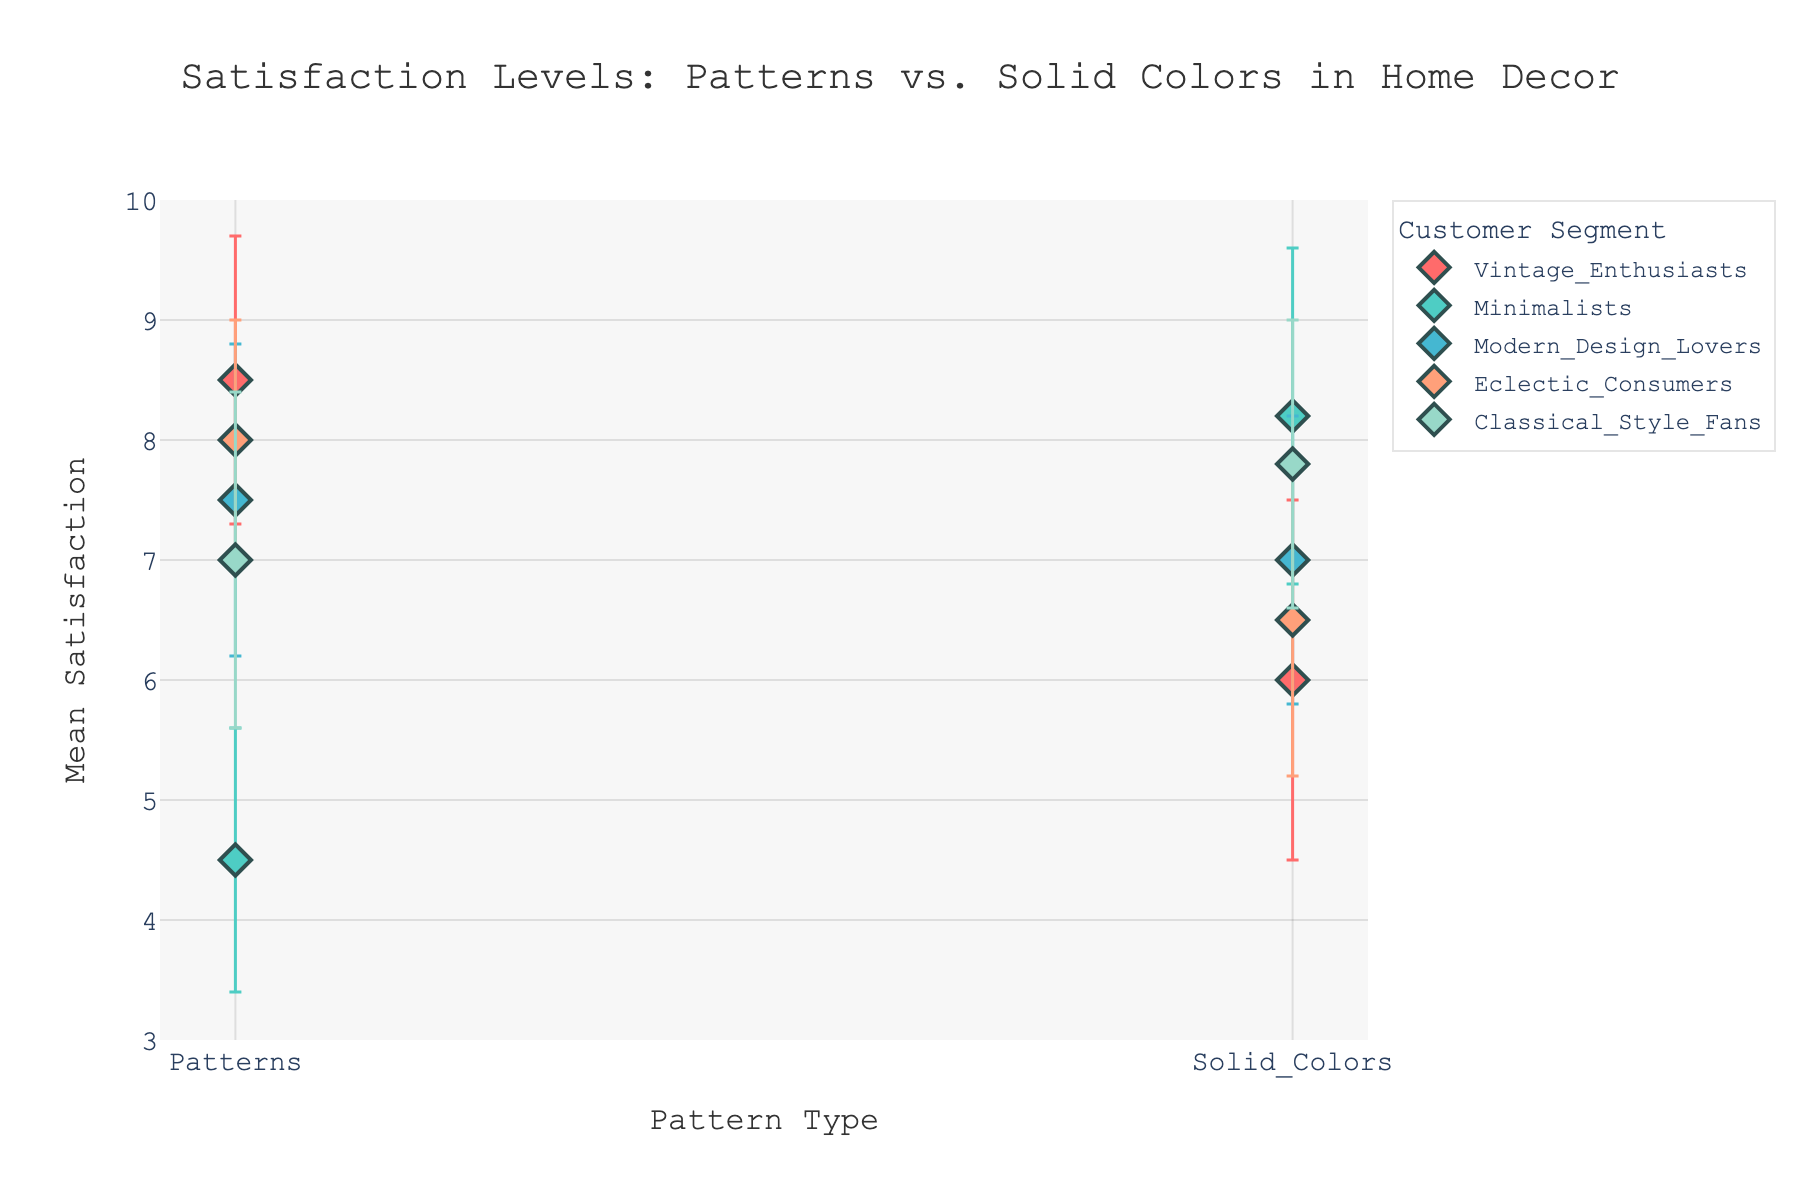What's the title of the figure? The title is located at the top of the figure. It reads: 'Satisfaction Levels: Patterns vs. Solid Colors in Home Decor'.
Answer: Satisfaction Levels: Patterns vs. Solid Colors in Home Decor Which customer segment has the highest mean satisfaction with patterns? By looking at the y-axis values for the 'Patterns' category for each customer segment, the segment with the highest satisfaction level is 'Vintage Enthusiasts' with a mean satisfaction of 8.5.
Answer: Vintage Enthusiasts What is the difference in mean satisfaction between Vintage Enthusiasts and Minimalists for solid colors? The mean satisfaction for Vintage Enthusiasts is 6.0 and for Minimalists is 8.2 in the 'Solid Colors' category. The difference is calculated as 8.2 - 6.0 = 2.2.
Answer: 2.2 Which customer segment shows the least variability in satisfaction for patterns? For each segment under 'Patterns', compare the standard deviations. The lowest standard deviation is 1.0, which belongs to 'Eclectic Consumers'.
Answer: Eclectic Consumers What is the range of the y-axis? The range of the y-axis indicates the spread of the plotted values. It goes from 3 to 10.
Answer: 3 to 10 Among the customer segments, which one shows the closest mean satisfaction between patterns and solid colors? By examining the plot, 'Modern Design Lovers' have mean satisfaction values of 7.5 (Patterns) and 7.0 (Solid Colors). The difference is minimal, which makes them the closest.
Answer: Modern Design Lovers What is the mean satisfaction for Classical Style Fans with solid colors? The plot shows that the mean satisfaction level on 'Solid Colors' for 'Classical Style Fans' is marked at 7.8 on the y-axis.
Answer: 7.8 What is the average mean satisfaction for Eclectic Consumers across both pattern types? Mean satisfaction for Eclectic Consumers is 8.0 (Patterns) and 6.5 (Solid Colors). The average is (8.0 + 6.5) / 2 = 7.25.
Answer: 7.25 Which customer segment has a higher mean satisfaction for solid colors compared to patterns? By comparing the mean satisfaction values, 'Minimalists' show a higher satisfaction level in 'Solid Colors' (8.2) compared to 'Patterns' (4.5).
Answer: Minimalists What is the error bar range for Vintage Enthusiasts with patterns? The mean satisfaction is 8.5 with a standard deviation of 1.2. Error bars range from 8.5 - 1.2 = 7.3 to 8.5 + 1.2 = 9.7.
Answer: 7.3 to 9.7 